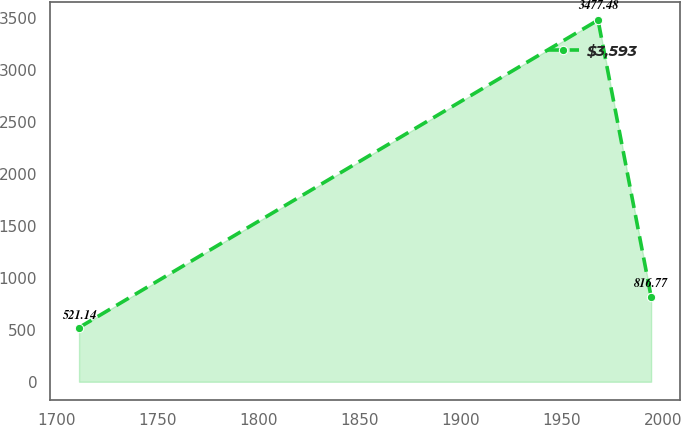Convert chart to OTSL. <chart><loc_0><loc_0><loc_500><loc_500><line_chart><ecel><fcel>$3,593<nl><fcel>1711.34<fcel>521.14<nl><fcel>1967.86<fcel>3477.48<nl><fcel>1994.09<fcel>816.77<nl></chart> 